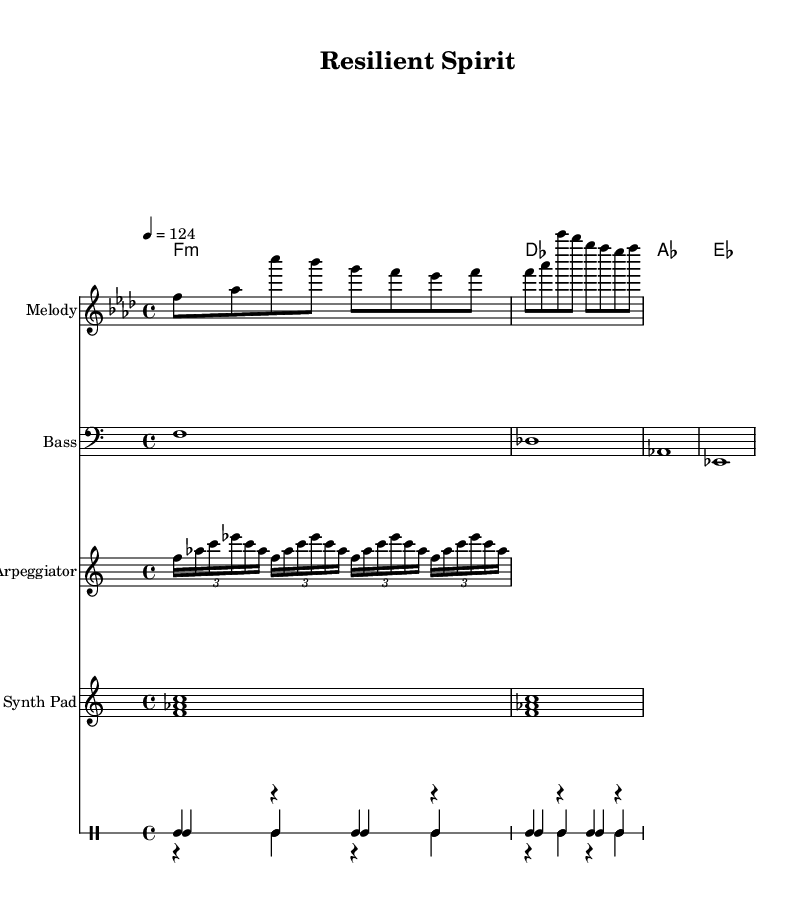What is the key signature of this music? The key signature is indicated by the key signature symbol at the beginning of the staff. It is F minor, which has four flats (B♭, E♭, A♭, D♭).
Answer: F minor What is the time signature of this piece? The time signature is shown right after the key signature. It is 4/4, meaning there are four beats in a measure, and the quarter note gets one beat.
Answer: 4/4 What is the tempo marking given in the score? The tempo marking is specified to the right of the time signature. It states "4 = 124," which indicates that there are 124 beats per minute.
Answer: 124 How many different instruments are included in the sheet music? The score shows multiple staffs, each representing a different instrument. There are five unique instruments listed: Melody, Bass, Arpeggiator, Synth Pad, and a Drum Staff.
Answer: Five What is the chord progression in the harmony section? By examining the chord symbols beneath the melody, the progression can be seen as F minor, D♭, A♭, E♭. Each chord represents a change in harmony throughout the piece.
Answer: F minor, D♭, A♭, E♭ What type of rhythmic variation does the arpeggiator contribute to the music? The arpeggiator utilizes tuplets of 3/2 to create subdivisions within the measures. This offers a syncopated rhythmic texture that contrasts with the straight rhythm of other instruments.
Answer: Tuplets How does the drum pattern enhance the melodic house genre? The drum pattern features a simple kick-snare-hat combination that provides a steady pulse, characteristic of house music, driving the beat and maintaining a danceable rhythm.
Answer: Steady pulse 